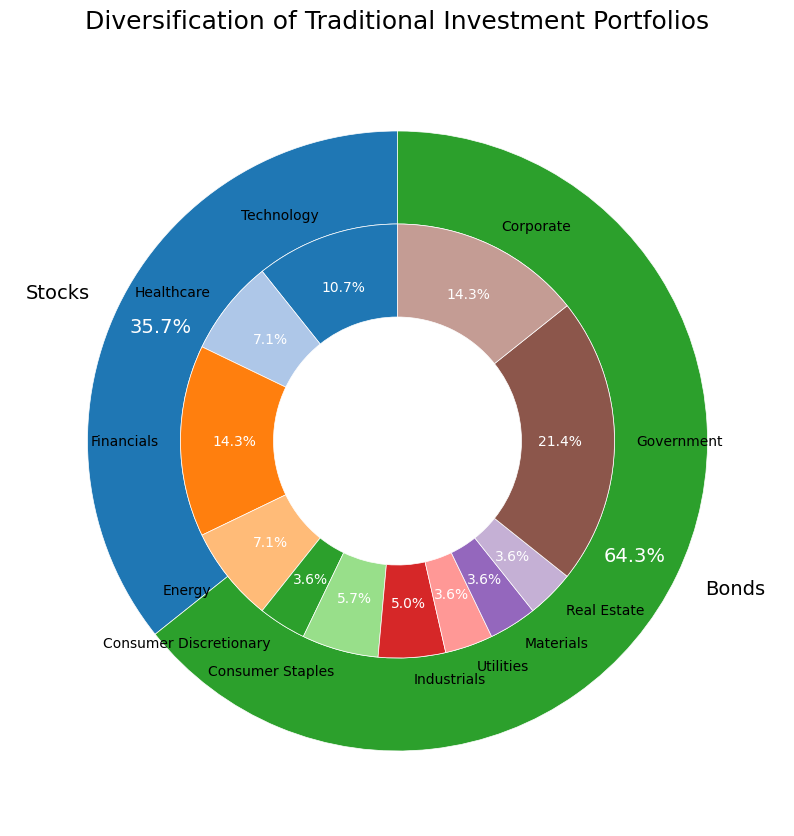What percentage of the total portfolio is allocated to stocks? The outer pie chart shows the total allocation separated by stocks and bonds. The segment labeled 'Stocks' shows the percentage of the total allocation.
Answer: 55% What is the combined percentage of the Financials and Technology sectors within the stock allocation? From the inner pie chart, Financials and Technology sectors are individually labeled. Financials is 20%, and Technology is 15%. Summing up these percentages gives the combined percentage.
Answer: 35% Which is larger: the allocation for Government bonds or the total allocation for the Energy and Industrials sectors? The Government bonds segment is labeled with its percentage, 60%, compared to Energy and Industrials segments of the inner pie chart, 10% and 7%, respectively. Government bonds have a greater percentage.
Answer: Government bonds What is the percentage difference between Corporate Bonds and Consumer Discretionary stocks in the portfolio? Corporate Bonds are labeled with 20%, and Consumer Discretionary stocks are labeled with 5% on the inner pie chart. Subtracting the percentages gives the difference.
Answer: 15% Is the allocation for Utilities stocks greater than or equal to the allocation for Materials stocks? From the inner pie chart, both Utilities and Materials stocks have their own percentage segments, which are both 5%.
Answer: Equal to How much larger is the allocation to Healthcare stocks compared to Real Estate stocks? The inner pie chart shows the percentages for Healthcare stocks and Real Estate stocks, which are 10% and 5%, respectively. Subtracting the Real Estate allocation from Healthcare allocation gives the difference.
Answer: 5% What is the second-largest sector in the stock allocation? The inner pie chart shows the individual sectors within the stock allocation. The second-largest sector is Healthcare with 10%, as the largest is Financials with 20%.
Answer: Healthcare What's the total percentage for Consumer-related sectors (Consumer Discretionary + Consumer Staples)? The inner pie chart segments for Consumer Discretionary and Consumer Staples are labeled. Adding their percentages (5% + 8%) gives the total percentage.
Answer: 13% Does the Energy sector have a lesser allocation than the Industrials sector? Inner pie chart segments for Energy and Industrials show their respective allocations, which are 10% for Energy and 7% for Industrials. Energy has a larger allocation.
Answer: No 